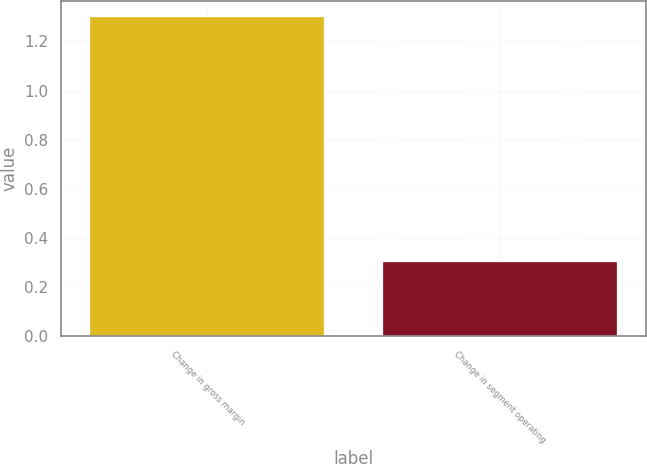Convert chart. <chart><loc_0><loc_0><loc_500><loc_500><bar_chart><fcel>Change in gross margin<fcel>Change in segment operating<nl><fcel>1.3<fcel>0.3<nl></chart> 